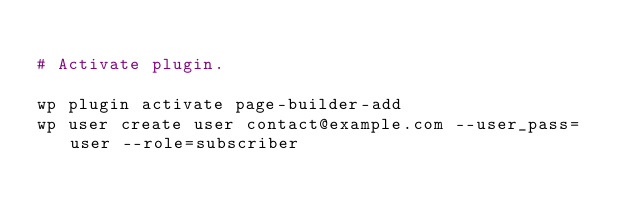Convert code to text. <code><loc_0><loc_0><loc_500><loc_500><_Bash_>
# Activate plugin.

wp plugin activate page-builder-add
wp user create user contact@example.com --user_pass=user --role=subscriber</code> 